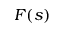<formula> <loc_0><loc_0><loc_500><loc_500>F ( s )</formula> 